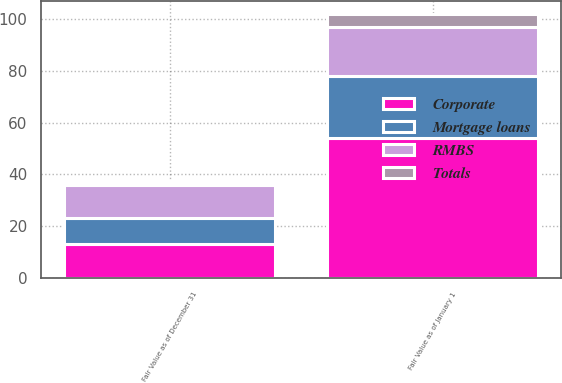Convert chart to OTSL. <chart><loc_0><loc_0><loc_500><loc_500><stacked_bar_chart><ecel><fcel>Fair Value as of January 1<fcel>Fair Value as of December 31<nl><fcel>RMBS<fcel>19<fcel>13<nl><fcel>Mortgage loans<fcel>24<fcel>10<nl><fcel>Totals<fcel>5<fcel>1<nl><fcel>Corporate<fcel>54<fcel>13<nl></chart> 